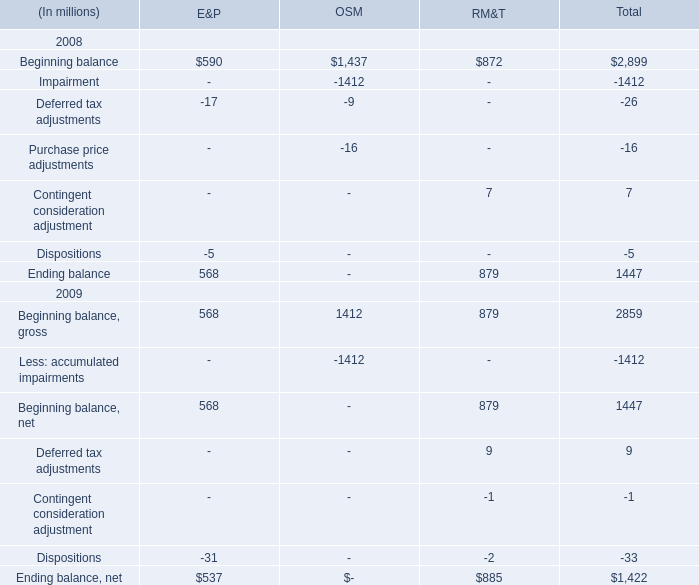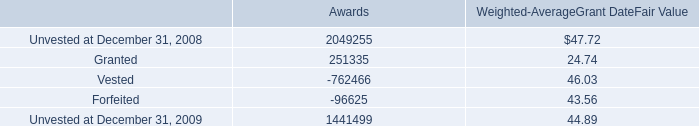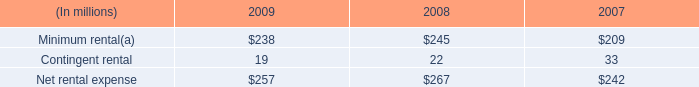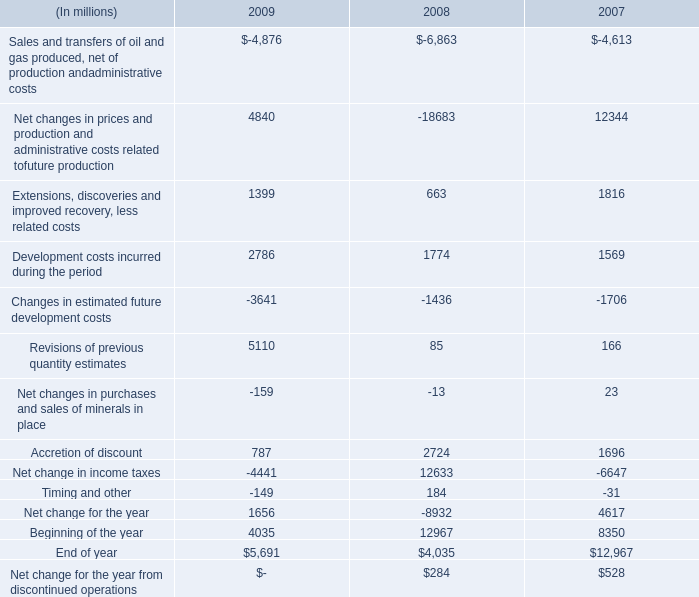how much did net rental expense increase from 2007 to 2009? 
Computations: ((257 - 242) / 242)
Answer: 0.06198. 